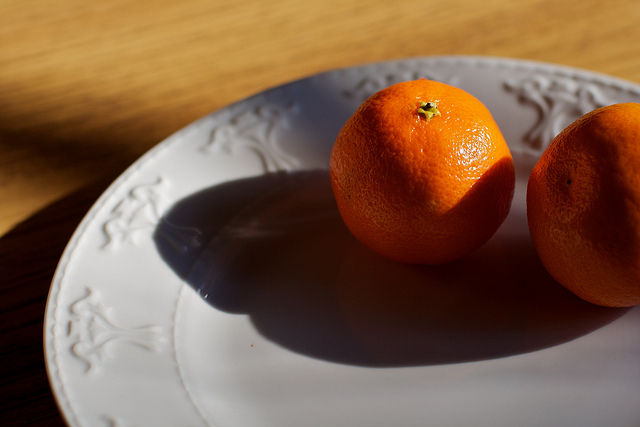What can you infer about the time and location given the context of the image? The warm lighting and the shadows cast suggest that the photo was taken in the early morning or late afternoon. The rustic wooden surface and the traditional design of the plate hint at a cozy, possibly rural or countryside setting. This environment evokes a sense of homeliness and simplicity, where natural light plays a significant role in the daily ambiance. 